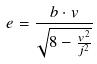Convert formula to latex. <formula><loc_0><loc_0><loc_500><loc_500>e = \frac { b \cdot v } { \sqrt { 8 - \frac { v ^ { 2 } } { j ^ { 2 } } } }</formula> 